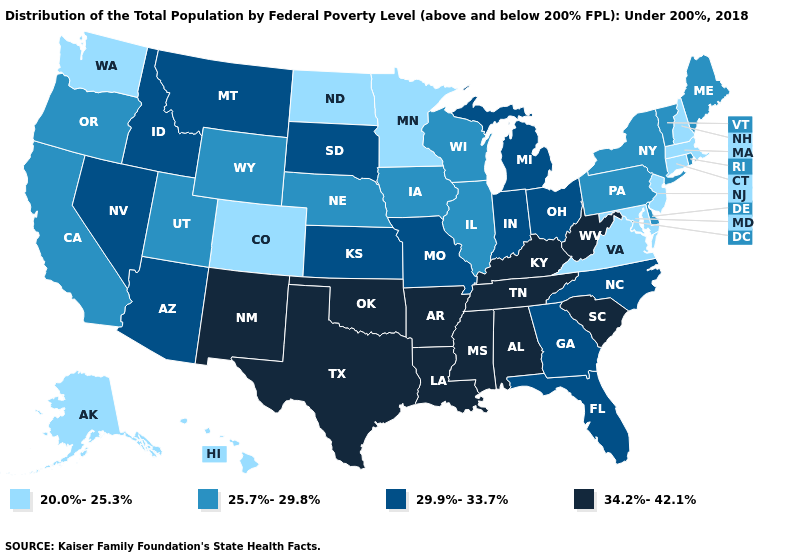Which states have the highest value in the USA?
Be succinct. Alabama, Arkansas, Kentucky, Louisiana, Mississippi, New Mexico, Oklahoma, South Carolina, Tennessee, Texas, West Virginia. Among the states that border Minnesota , which have the lowest value?
Short answer required. North Dakota. What is the value of Alaska?
Answer briefly. 20.0%-25.3%. Among the states that border Missouri , does Oklahoma have the lowest value?
Write a very short answer. No. What is the value of Arizona?
Write a very short answer. 29.9%-33.7%. What is the value of Montana?
Be succinct. 29.9%-33.7%. What is the lowest value in the South?
Keep it brief. 20.0%-25.3%. Among the states that border Arizona , which have the highest value?
Short answer required. New Mexico. Which states have the lowest value in the USA?
Short answer required. Alaska, Colorado, Connecticut, Hawaii, Maryland, Massachusetts, Minnesota, New Hampshire, New Jersey, North Dakota, Virginia, Washington. What is the value of Wisconsin?
Be succinct. 25.7%-29.8%. Does Indiana have the same value as Delaware?
Answer briefly. No. Does the map have missing data?
Keep it brief. No. Does the first symbol in the legend represent the smallest category?
Be succinct. Yes. Does Massachusetts have the same value as New Jersey?
Answer briefly. Yes. Does Hawaii have the lowest value in the USA?
Quick response, please. Yes. 